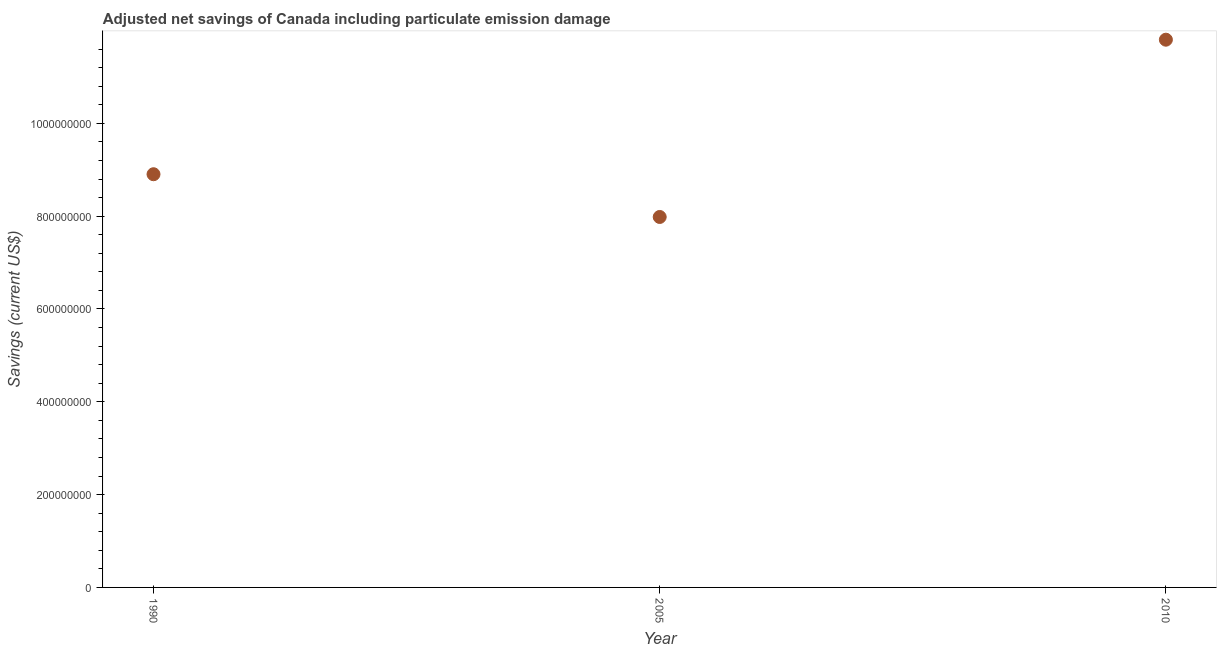What is the adjusted net savings in 2005?
Your answer should be compact. 7.98e+08. Across all years, what is the maximum adjusted net savings?
Your answer should be compact. 1.18e+09. Across all years, what is the minimum adjusted net savings?
Give a very brief answer. 7.98e+08. In which year was the adjusted net savings maximum?
Give a very brief answer. 2010. What is the sum of the adjusted net savings?
Your answer should be very brief. 2.87e+09. What is the difference between the adjusted net savings in 2005 and 2010?
Your response must be concise. -3.82e+08. What is the average adjusted net savings per year?
Your answer should be compact. 9.56e+08. What is the median adjusted net savings?
Offer a very short reply. 8.90e+08. In how many years, is the adjusted net savings greater than 720000000 US$?
Keep it short and to the point. 3. Do a majority of the years between 1990 and 2010 (inclusive) have adjusted net savings greater than 320000000 US$?
Ensure brevity in your answer.  Yes. What is the ratio of the adjusted net savings in 1990 to that in 2005?
Your response must be concise. 1.12. Is the difference between the adjusted net savings in 1990 and 2005 greater than the difference between any two years?
Offer a very short reply. No. What is the difference between the highest and the second highest adjusted net savings?
Give a very brief answer. 2.90e+08. What is the difference between the highest and the lowest adjusted net savings?
Offer a very short reply. 3.82e+08. How many years are there in the graph?
Your answer should be very brief. 3. Does the graph contain any zero values?
Offer a terse response. No. What is the title of the graph?
Make the answer very short. Adjusted net savings of Canada including particulate emission damage. What is the label or title of the X-axis?
Your answer should be very brief. Year. What is the label or title of the Y-axis?
Your answer should be very brief. Savings (current US$). What is the Savings (current US$) in 1990?
Offer a terse response. 8.90e+08. What is the Savings (current US$) in 2005?
Your answer should be compact. 7.98e+08. What is the Savings (current US$) in 2010?
Your answer should be very brief. 1.18e+09. What is the difference between the Savings (current US$) in 1990 and 2005?
Provide a short and direct response. 9.21e+07. What is the difference between the Savings (current US$) in 1990 and 2010?
Ensure brevity in your answer.  -2.90e+08. What is the difference between the Savings (current US$) in 2005 and 2010?
Your answer should be compact. -3.82e+08. What is the ratio of the Savings (current US$) in 1990 to that in 2005?
Make the answer very short. 1.11. What is the ratio of the Savings (current US$) in 1990 to that in 2010?
Provide a short and direct response. 0.75. What is the ratio of the Savings (current US$) in 2005 to that in 2010?
Offer a very short reply. 0.68. 